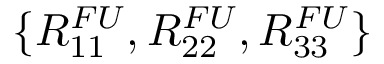<formula> <loc_0><loc_0><loc_500><loc_500>\{ R _ { 1 1 } ^ { F U } , R _ { 2 2 } ^ { F U } , R _ { 3 3 } ^ { F U } \}</formula> 